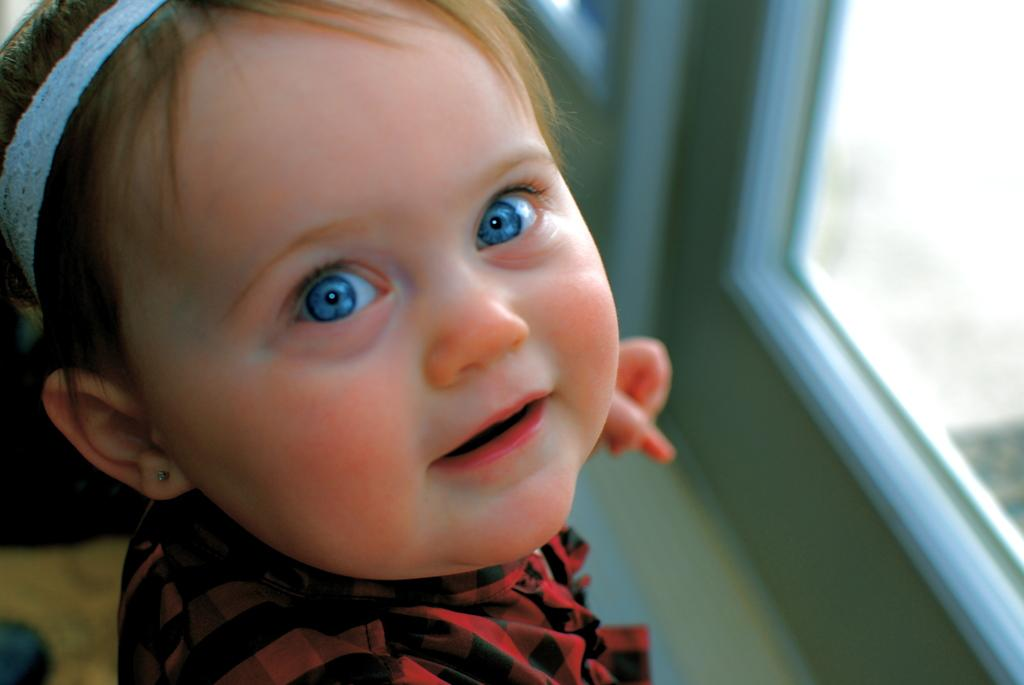What is the main subject of the image? The main subject of the image is a kid. What is the kid wearing on their head? The kid is wearing a headband. What is the kid's facial expression in the image? The kid is smiling. Can you describe the background of the image? The background of the image is blurred. What type of structure can be seen in the image? There is a glass window in the image. What surface is visible in the image? There is a floor visible in the image. What type of game is the kid playing on the canvas in the image? There is no canvas or game present in the image; it features a kid wearing a headband and smiling. 